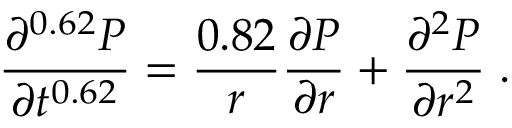Convert formula to latex. <formula><loc_0><loc_0><loc_500><loc_500>\frac { \partial ^ { 0 . 6 2 } P } { \partial t ^ { 0 . 6 2 } } = \frac { 0 . 8 2 } { r } \frac { \partial P } { \partial r } + \frac { \partial ^ { 2 } P } { \partial r ^ { 2 } } \, .</formula> 